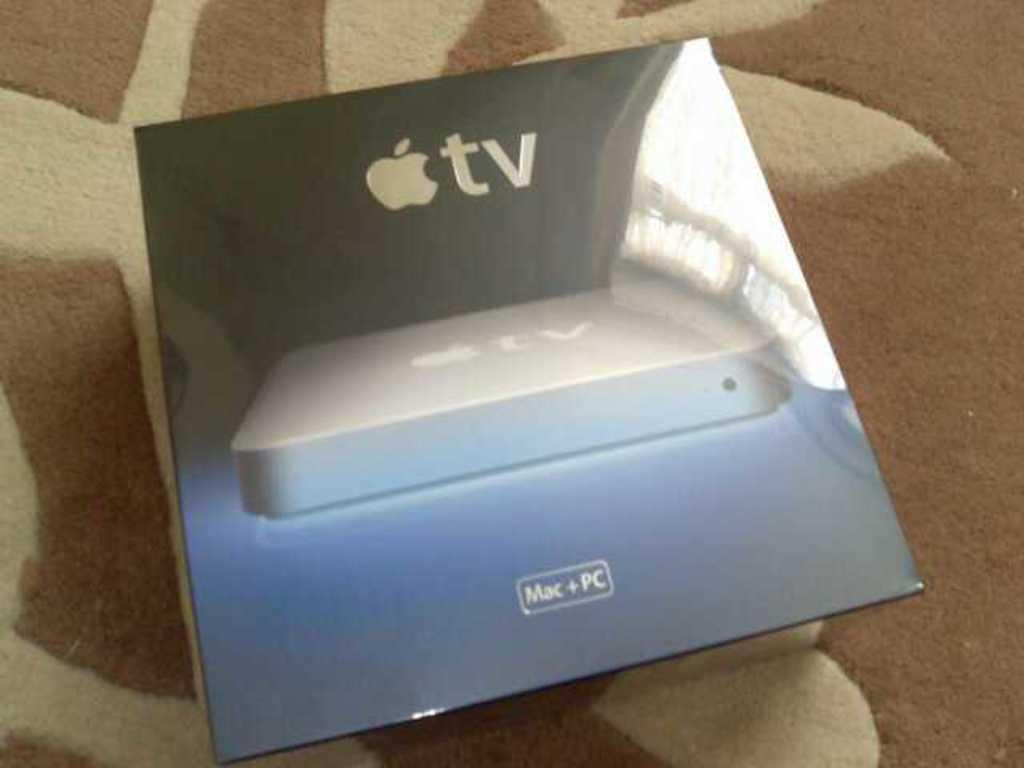<image>
Summarize the visual content of the image. A box labeled Apple Tv on a beige and white rug. 